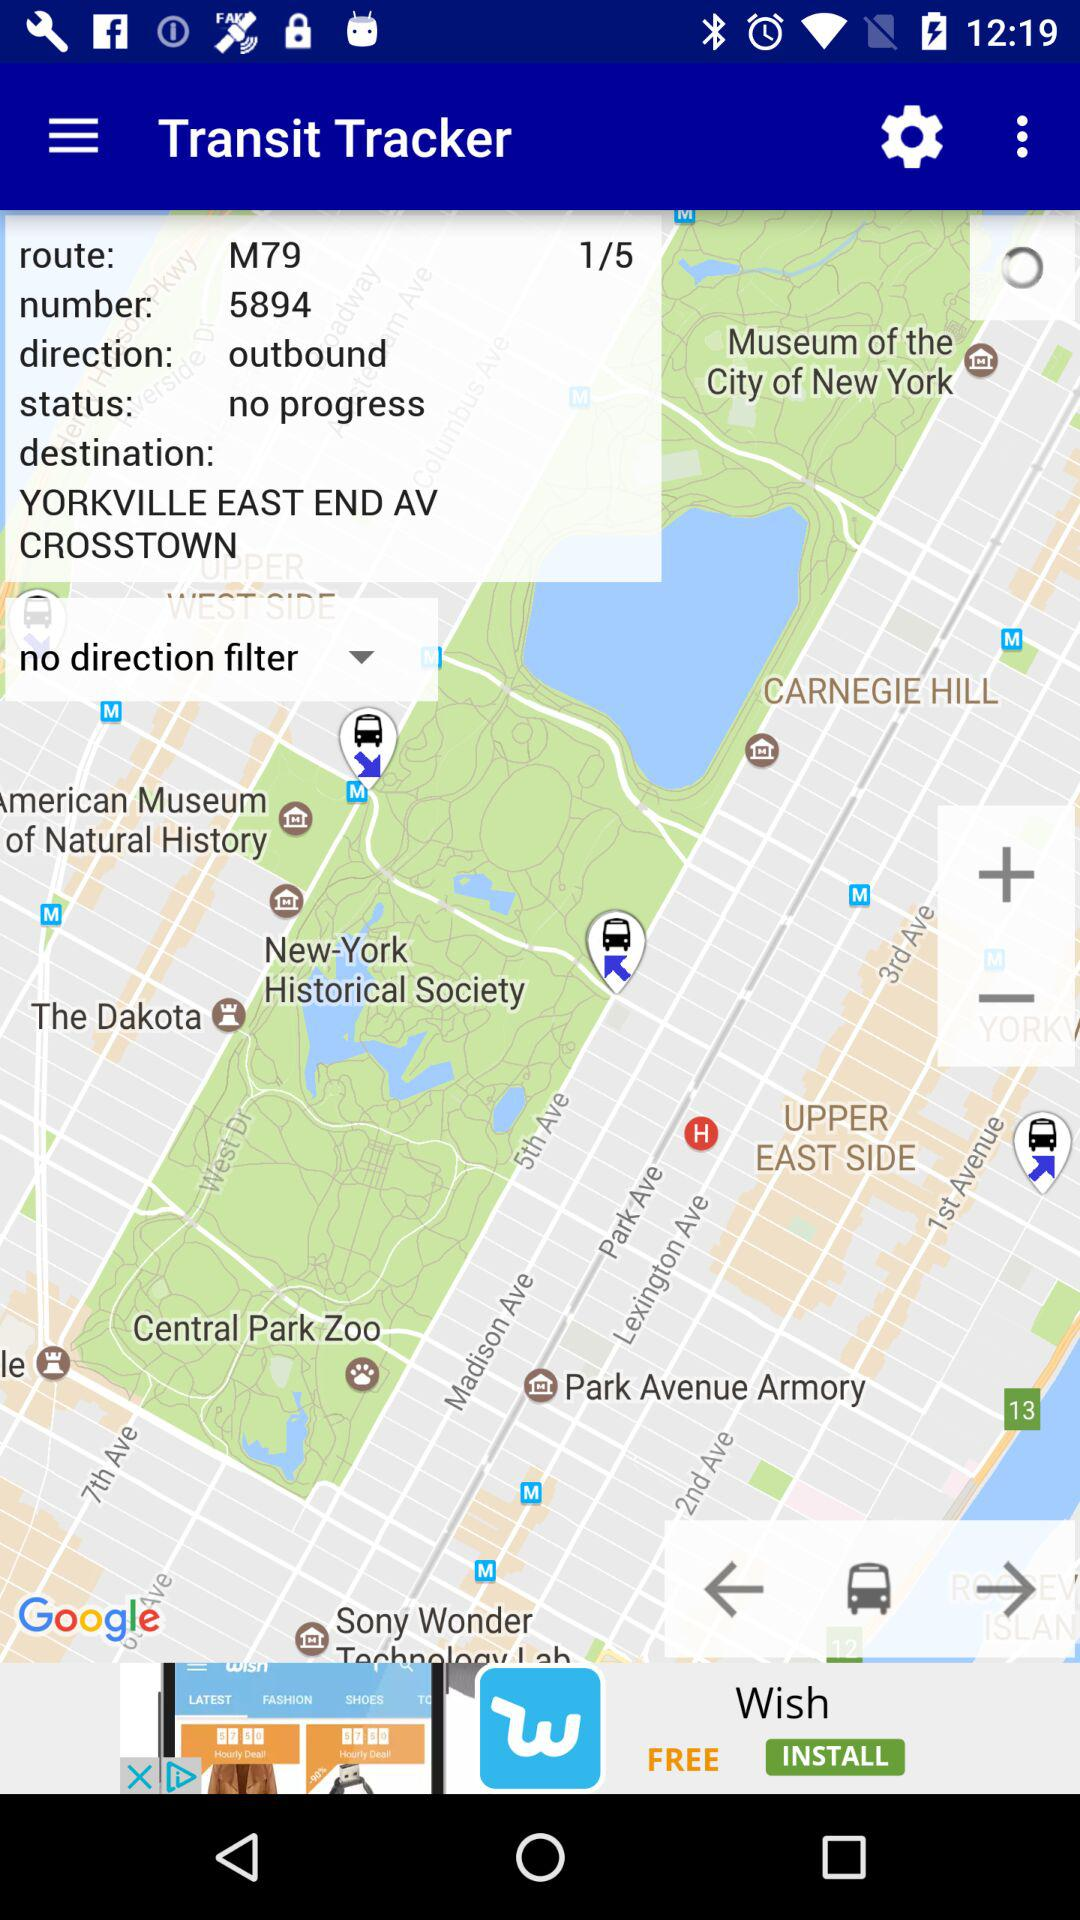What's the destination? The destination is Yorkville, East End Avenue, Crosstown. 